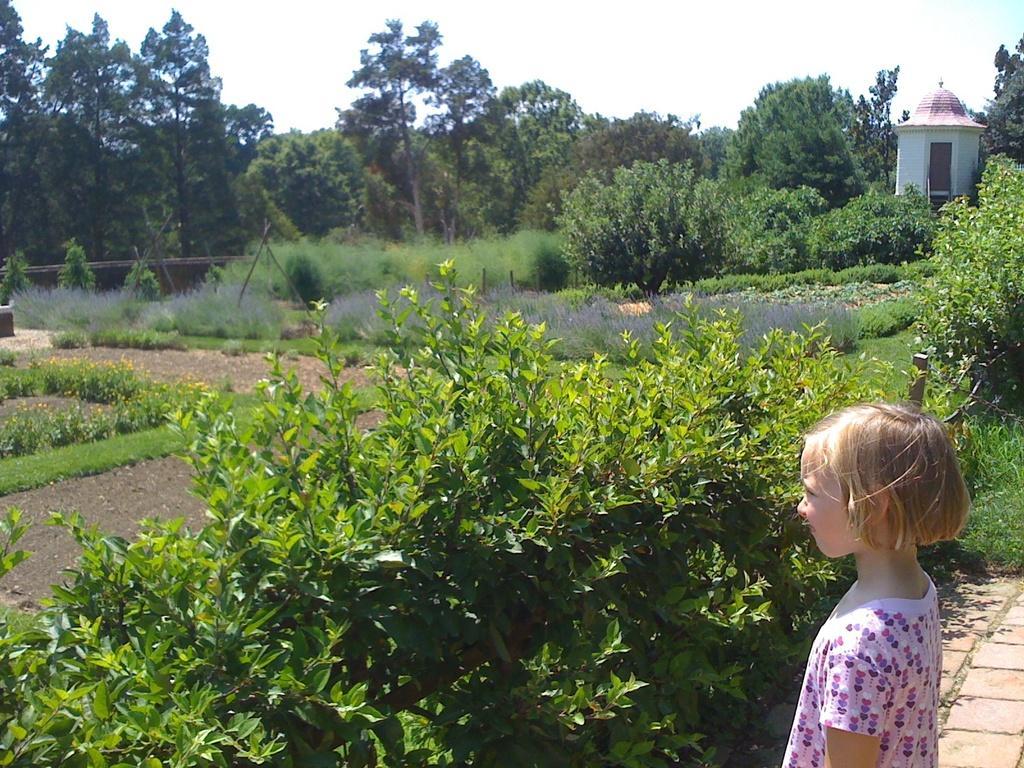Could you give a brief overview of what you see in this image? In this picture we can see a girl, she is standing in front of the plants, in the background we can see a room and few trees. 